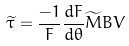<formula> <loc_0><loc_0><loc_500><loc_500>\widetilde { \tau } = \frac { - 1 } { F } \frac { d F } { d \theta } \widetilde { M } B V</formula> 